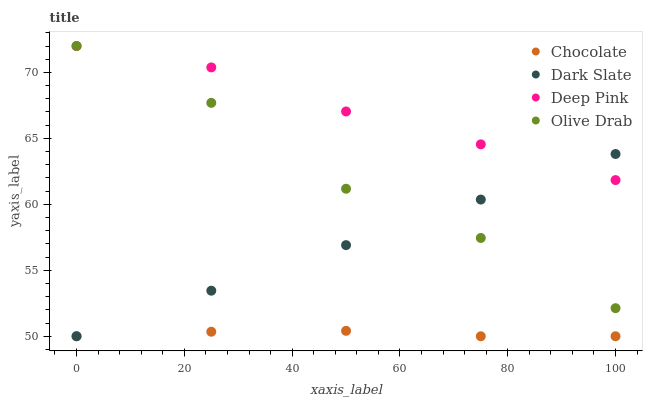Does Chocolate have the minimum area under the curve?
Answer yes or no. Yes. Does Deep Pink have the maximum area under the curve?
Answer yes or no. Yes. Does Olive Drab have the minimum area under the curve?
Answer yes or no. No. Does Olive Drab have the maximum area under the curve?
Answer yes or no. No. Is Dark Slate the smoothest?
Answer yes or no. Yes. Is Olive Drab the roughest?
Answer yes or no. Yes. Is Deep Pink the smoothest?
Answer yes or no. No. Is Deep Pink the roughest?
Answer yes or no. No. Does Dark Slate have the lowest value?
Answer yes or no. Yes. Does Olive Drab have the lowest value?
Answer yes or no. No. Does Olive Drab have the highest value?
Answer yes or no. Yes. Does Chocolate have the highest value?
Answer yes or no. No. Is Chocolate less than Deep Pink?
Answer yes or no. Yes. Is Deep Pink greater than Chocolate?
Answer yes or no. Yes. Does Olive Drab intersect Dark Slate?
Answer yes or no. Yes. Is Olive Drab less than Dark Slate?
Answer yes or no. No. Is Olive Drab greater than Dark Slate?
Answer yes or no. No. Does Chocolate intersect Deep Pink?
Answer yes or no. No. 